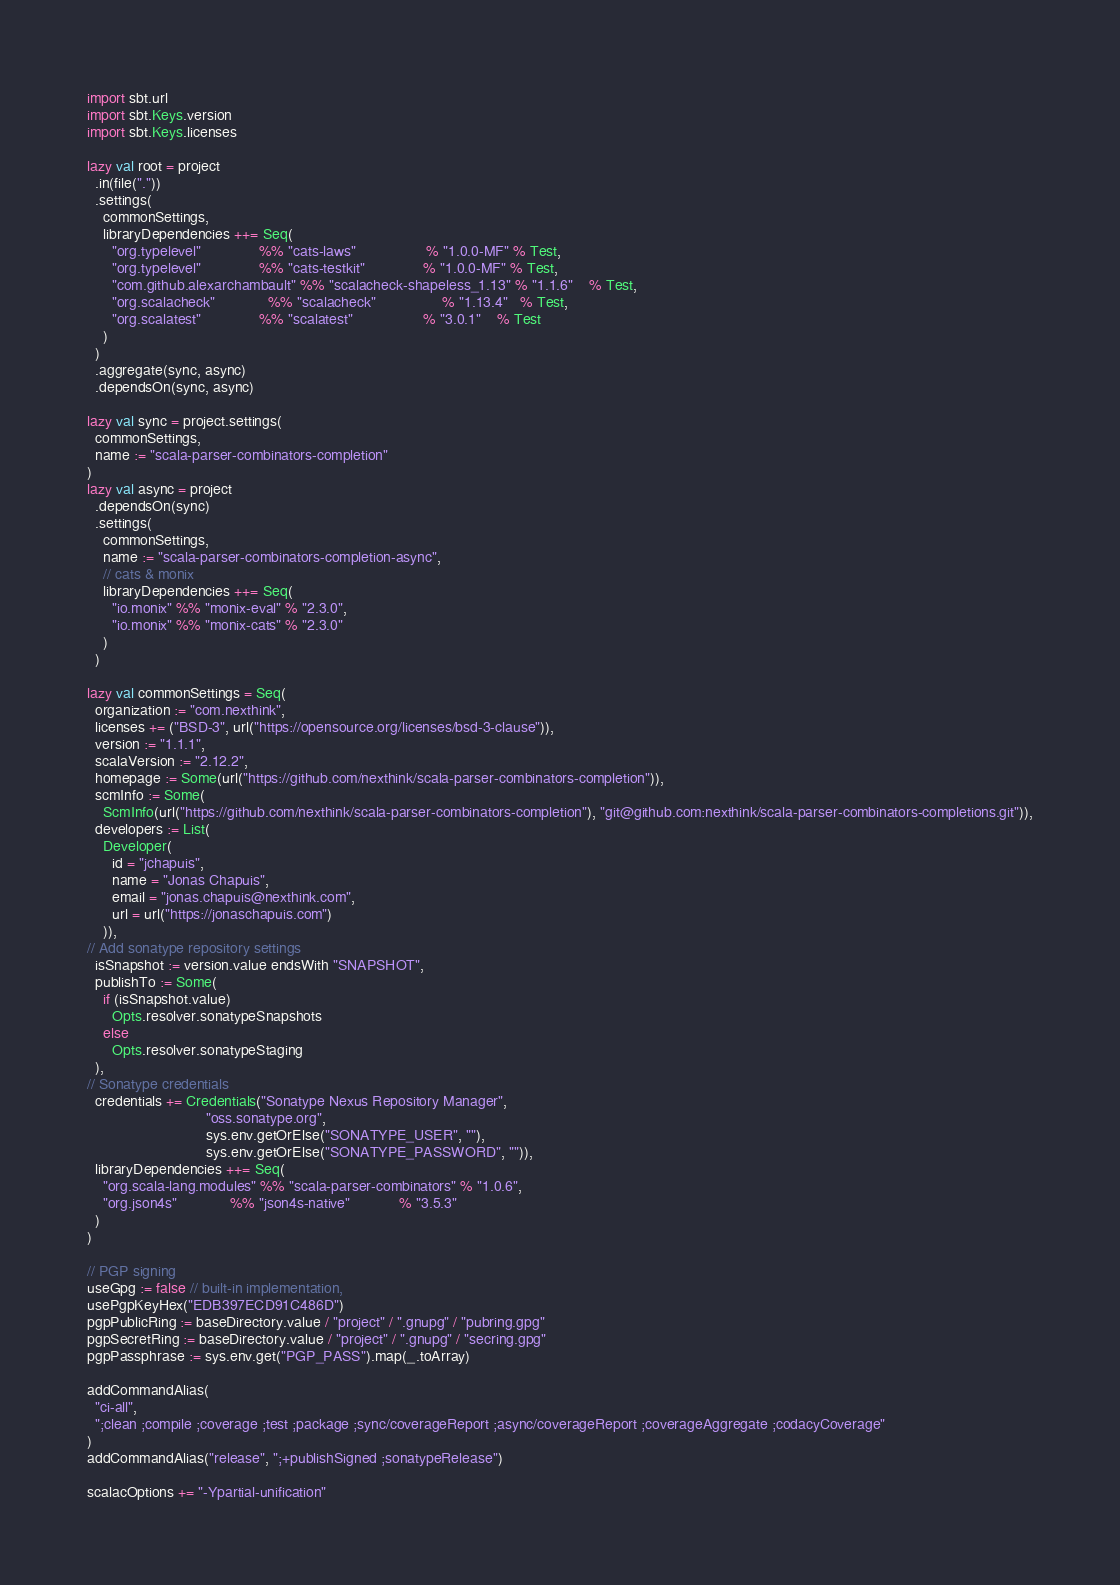Convert code to text. <code><loc_0><loc_0><loc_500><loc_500><_Scala_>import sbt.url
import sbt.Keys.version
import sbt.Keys.licenses

lazy val root = project
  .in(file("."))
  .settings(
    commonSettings,
    libraryDependencies ++= Seq(
      "org.typelevel"              %% "cats-laws"                 % "1.0.0-MF" % Test,
      "org.typelevel"              %% "cats-testkit"              % "1.0.0-MF" % Test,
      "com.github.alexarchambault" %% "scalacheck-shapeless_1.13" % "1.1.6"    % Test,
      "org.scalacheck"             %% "scalacheck"                % "1.13.4"   % Test,
      "org.scalatest"              %% "scalatest"                 % "3.0.1"    % Test
    )
  )
  .aggregate(sync, async)
  .dependsOn(sync, async)

lazy val sync = project.settings(
  commonSettings,
  name := "scala-parser-combinators-completion"
)
lazy val async = project
  .dependsOn(sync)
  .settings(
    commonSettings,
    name := "scala-parser-combinators-completion-async",
    // cats & monix
    libraryDependencies ++= Seq(
      "io.monix" %% "monix-eval" % "2.3.0",
      "io.monix" %% "monix-cats" % "2.3.0"
    )
  )

lazy val commonSettings = Seq(
  organization := "com.nexthink",
  licenses += ("BSD-3", url("https://opensource.org/licenses/bsd-3-clause")),
  version := "1.1.1",
  scalaVersion := "2.12.2",
  homepage := Some(url("https://github.com/nexthink/scala-parser-combinators-completion")),
  scmInfo := Some(
    ScmInfo(url("https://github.com/nexthink/scala-parser-combinators-completion"), "git@github.com:nexthink/scala-parser-combinators-completions.git")),
  developers := List(
    Developer(
      id = "jchapuis",
      name = "Jonas Chapuis",
      email = "jonas.chapuis@nexthink.com",
      url = url("https://jonaschapuis.com")
    )),
// Add sonatype repository settings
  isSnapshot := version.value endsWith "SNAPSHOT",
  publishTo := Some(
    if (isSnapshot.value)
      Opts.resolver.sonatypeSnapshots
    else
      Opts.resolver.sonatypeStaging
  ),
// Sonatype credentials
  credentials += Credentials("Sonatype Nexus Repository Manager",
                             "oss.sonatype.org",
                             sys.env.getOrElse("SONATYPE_USER", ""),
                             sys.env.getOrElse("SONATYPE_PASSWORD", "")),
  libraryDependencies ++= Seq(
    "org.scala-lang.modules" %% "scala-parser-combinators" % "1.0.6",
    "org.json4s"             %% "json4s-native"            % "3.5.3"
  )
)

// PGP signing
useGpg := false // built-in implementation,
usePgpKeyHex("EDB397ECD91C486D")
pgpPublicRing := baseDirectory.value / "project" / ".gnupg" / "pubring.gpg"
pgpSecretRing := baseDirectory.value / "project" / ".gnupg" / "secring.gpg"
pgpPassphrase := sys.env.get("PGP_PASS").map(_.toArray)

addCommandAlias(
  "ci-all",
  ";clean ;compile ;coverage ;test ;package ;sync/coverageReport ;async/coverageReport ;coverageAggregate ;codacyCoverage"
)
addCommandAlias("release", ";+publishSigned ;sonatypeRelease")

scalacOptions += "-Ypartial-unification"
</code> 